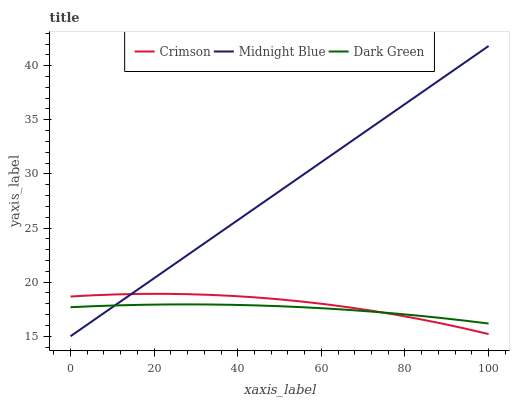Does Dark Green have the minimum area under the curve?
Answer yes or no. Yes. Does Midnight Blue have the maximum area under the curve?
Answer yes or no. Yes. Does Midnight Blue have the minimum area under the curve?
Answer yes or no. No. Does Dark Green have the maximum area under the curve?
Answer yes or no. No. Is Midnight Blue the smoothest?
Answer yes or no. Yes. Is Crimson the roughest?
Answer yes or no. Yes. Is Dark Green the smoothest?
Answer yes or no. No. Is Dark Green the roughest?
Answer yes or no. No. Does Midnight Blue have the lowest value?
Answer yes or no. Yes. Does Dark Green have the lowest value?
Answer yes or no. No. Does Midnight Blue have the highest value?
Answer yes or no. Yes. Does Dark Green have the highest value?
Answer yes or no. No. Does Dark Green intersect Crimson?
Answer yes or no. Yes. Is Dark Green less than Crimson?
Answer yes or no. No. Is Dark Green greater than Crimson?
Answer yes or no. No. 